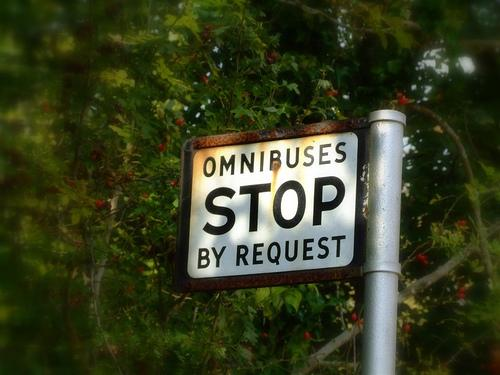Describe the condition of the sign's border in this image. The border of the sign is rusted with rust spots on the top and bottom parts. Point out the two smallest elements on the sign in this image. The letter 'i' and the rust stain on the sign are the two smallest elements. What are two noticeable features of the pole that the sign is mounted on? The pole is gray and has a metal sign bracket on it. Describe the most significant object in the image related to the bus stop. The bus stop information sign with directions and other details is the most significant object. What colors are the word "stop" written in and what is it placed on? The word "stop" is written in black on a white sign. What does the sign with the word "stop" on it indicate? It indicates that the location is a bus stop where buses will stop. Explain the primary purpose of the object found in the image. The main object is an information sign for a bus stop which gives instructions and details related to the bus stop. Identify three elements mentioned on the sign besides the word "stop." The words 'By Request', 'Omnibuses' and an individual letter 'Q'. Please describe the surroundings in the background of the image. The background has blurry leaf-covered trees with green leaves and red berries. In a few words, describe the state of the frame around the sign. The frame is rusted and has rust spots at the top and bottom. 